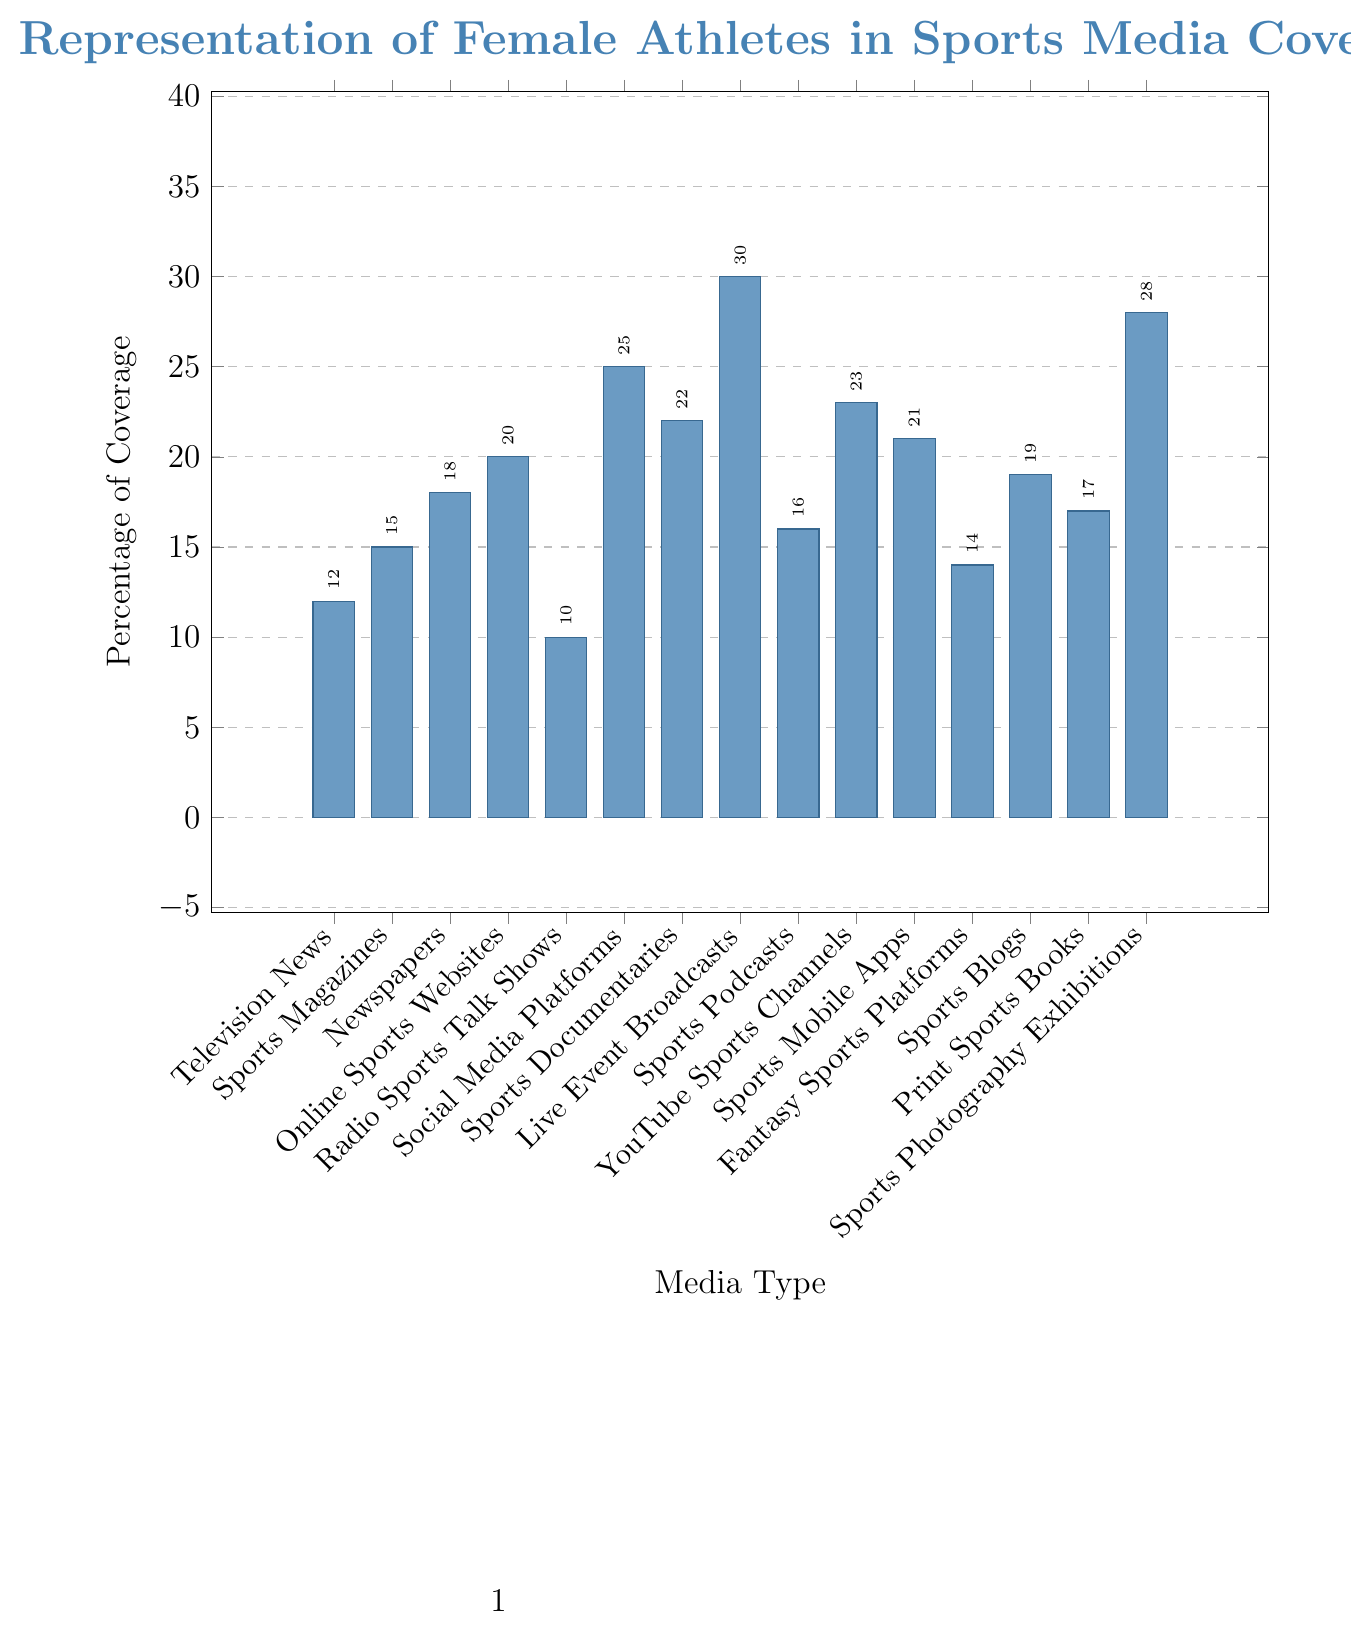What media type has the highest percentage of coverage for female athletes? The highest bar indicates the media type with the highest percentage. Live Event Broadcasts have the highest bar at 30%.
Answer: Live Event Broadcasts Which media type provides the least coverage for female athletes? The shortest bar indicates the media type with the least coverage. Radio Sports Talk Shows have the shortest bar at 10%.
Answer: Radio Sports Talk Shows How does the coverage of Social Media Platforms compare to YouTube Sports Channels? The height of the bars for Social Media Platforms and YouTube Sports Channels should be compared. Social Media Platforms have a coverage of 25%, while YouTube Sports Channels have 23%.
Answer: Social Media Platforms have higher coverage What is the combined percentage of coverage for Sports Magazines and Newspapers? Add the percentage coverage for Sports Magazines (15%) and Newspapers (18%). 15 + 18 = 33.
Answer: 33% What's the difference in coverage percentage between Live Event Broadcasts and Fantasy Sports Platforms? Subtract the coverage of Fantasy Sports Platforms (14%) from Live Event Broadcasts (30%). 30 - 14 = 16.
Answer: 16% Which media types have coverage percentages between 20% and 25%? Identify all bars with heights corresponding to percentages between 20% and 25%. They include Online Sports Websites (20%), Sports Documentaries (22%), Sports Mobile Apps (21%), and YouTube Sports Channels (23%).
Answer: Online Sports Websites, Sports Documentaries, Sports Mobile Apps, YouTube Sports Channels How much more coverage do Live Event Broadcasts have compared to Radio Sports Talk Shows? Subtract the coverage of Radio Sports Talk Shows (10%) from Live Event Broadcasts (30%). 30 - 10 = 20.
Answer: 20% What is the average percentage of coverage across all media types? Sum the percentages and divide by the number of data points: (12 + 15 + 18 + 20 + 10 + 25 + 22 + 30 + 16 + 23 + 21 + 14 + 19 + 17 + 28) / 15 = 290 / 15 ≈ 19.33. The average coverage is about 19.33%.
Answer: 19.33% Are there more media types with coverage below or above 20%? Count the number of media types with coverage below and above 20%. There are 8 media types below 20% and 7 media types above 20%.
Answer: More media types below 20% 